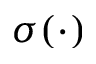<formula> <loc_0><loc_0><loc_500><loc_500>\sigma ( \cdot )</formula> 